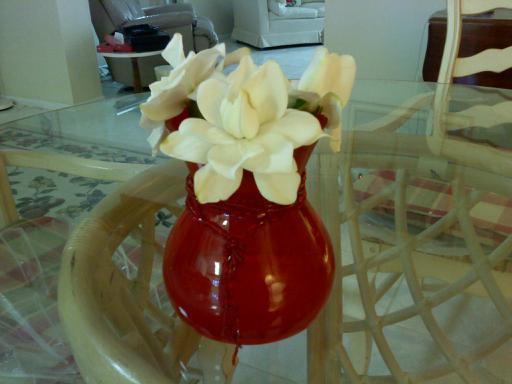How many colors are on the vase?
Give a very brief answer. 1. How many chairs are visible?
Give a very brief answer. 3. How many couches are visible?
Give a very brief answer. 2. 